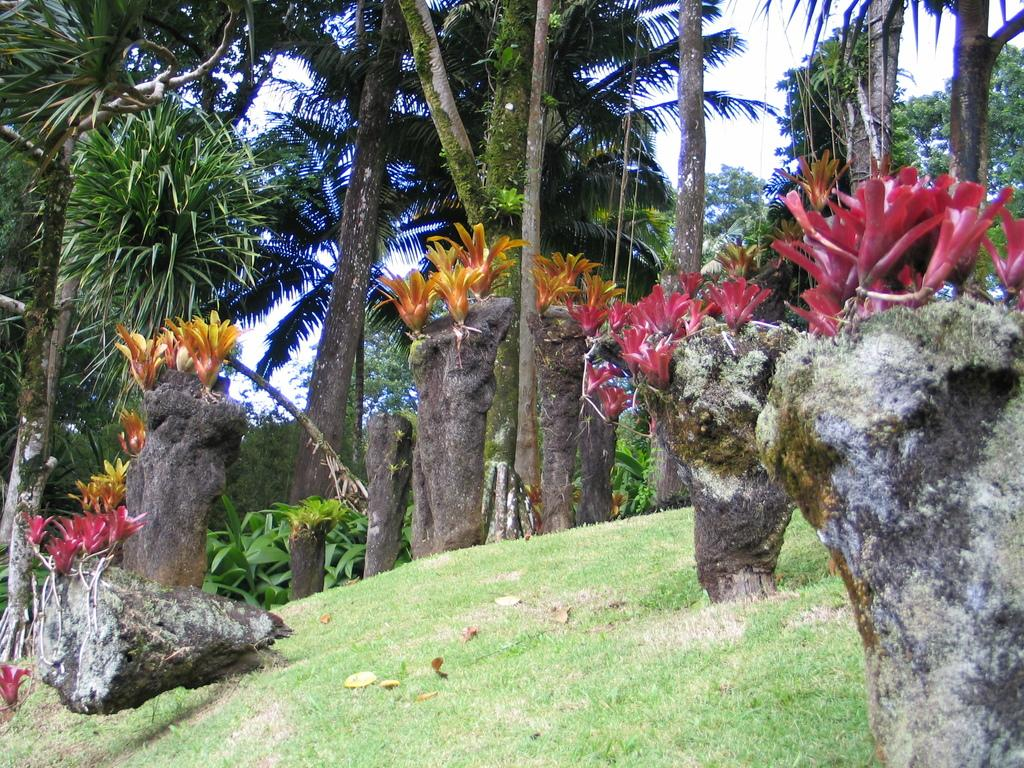What type of plants are visible in the image? There is a group of flowers on plants in the image. What type of vegetation is in the foreground of the image? There is grass in the foreground of the image. What type of plants are in the background of the image? There is a group of trees in the background of the image. What is visible in the background of the image besides the trees? The sky is visible in the background of the image. What type of pet can be seen wearing apparel in the image? There is no pet visible in the image, let alone one wearing apparel. What type of nut is growing on the trees in the background of the image? There is no nut visible in the image; the trees in the background are not specified as nut-bearing trees. 